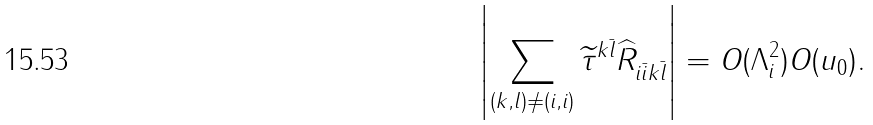<formula> <loc_0><loc_0><loc_500><loc_500>\left | \sum _ { ( k , l ) \ne ( i , i ) } \widetilde { \tau } ^ { k \bar { l } } \widehat { R } _ { i \bar { i } k \bar { l } } \right | = O ( \Lambda _ { i } ^ { 2 } ) O ( u _ { 0 } ) .</formula> 